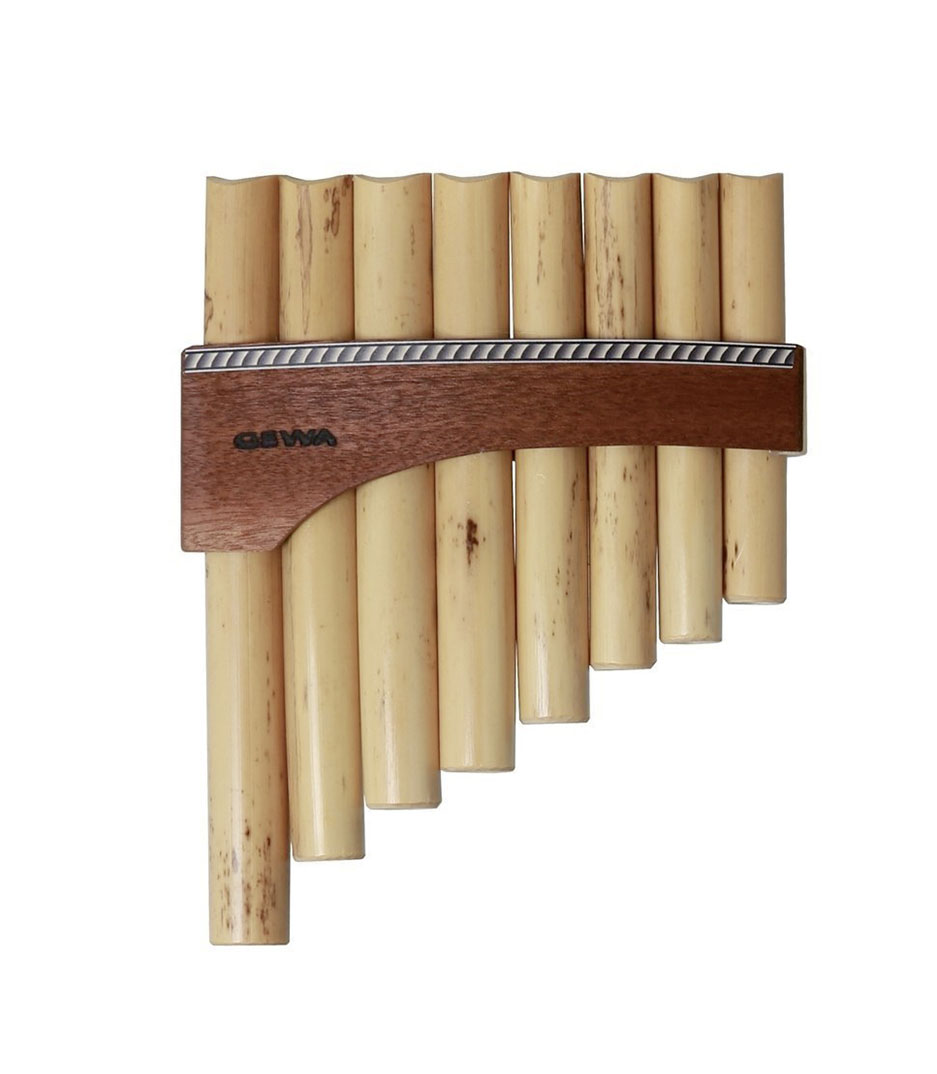What if this pan flute was an artifact in a fantasy adventure story? In a land of magic and mystery, this pan flute was no ordinary instrument. Forged by ancient spirits in the depths of an enchanted forest, each pipe was imbued with celestial power. Legends spoke of a hero who would one day arise to claim the flute, using its melodies to awaken ancient guardians and restore peace to the realm. The hero, driven by destiny, would embark on a quest across treacherous lands, facing mythical creatures and solving arcane puzzles. Only by mastering the pan flute's harmonious magic could balance be restored, delivering the realm from the shadow of darkness. 